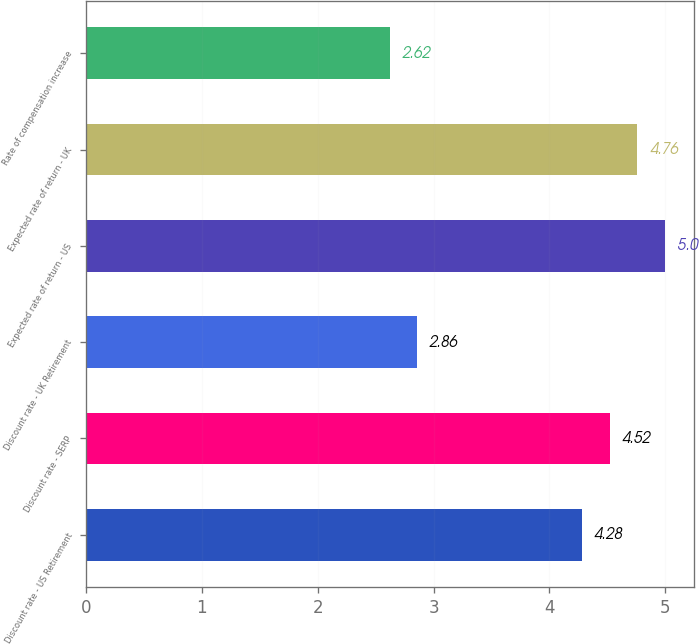<chart> <loc_0><loc_0><loc_500><loc_500><bar_chart><fcel>Discount rate - US Retirement<fcel>Discount rate - SERP<fcel>Discount rate - UK Retirement<fcel>Expected rate of return - US<fcel>Expected rate of return - UK<fcel>Rate of compensation increase<nl><fcel>4.28<fcel>4.52<fcel>2.86<fcel>5<fcel>4.76<fcel>2.62<nl></chart> 